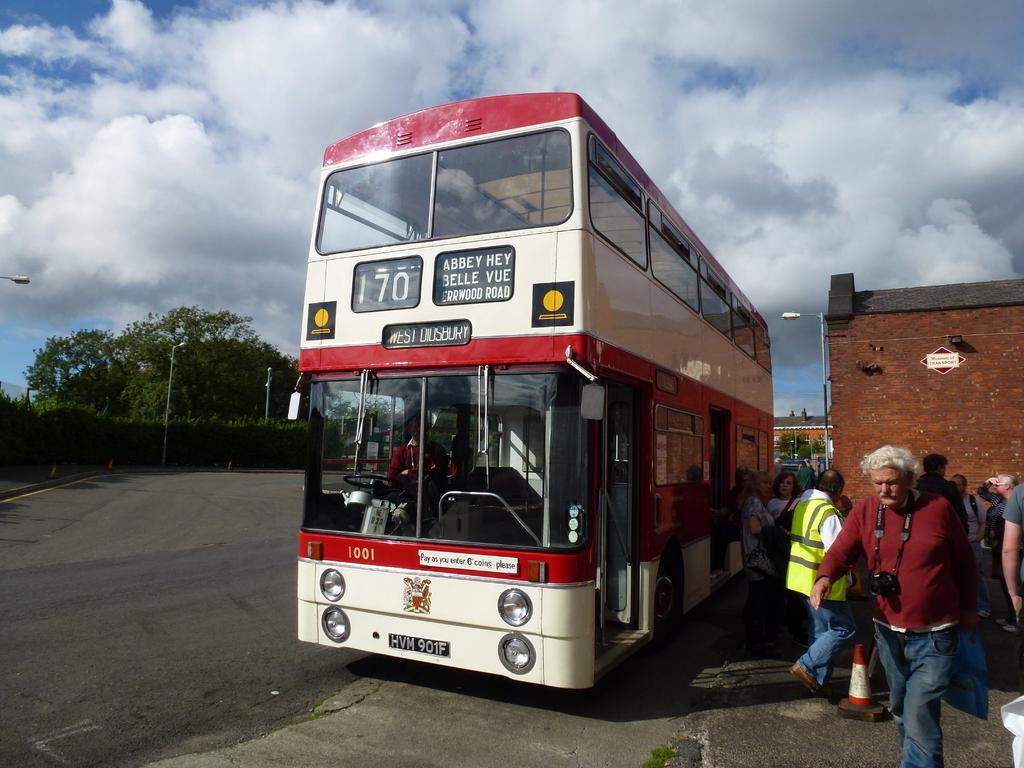<image>
Summarize the visual content of the image. A red and white double decker bus with a sign that says "Pay as you enter 6 coins please" 